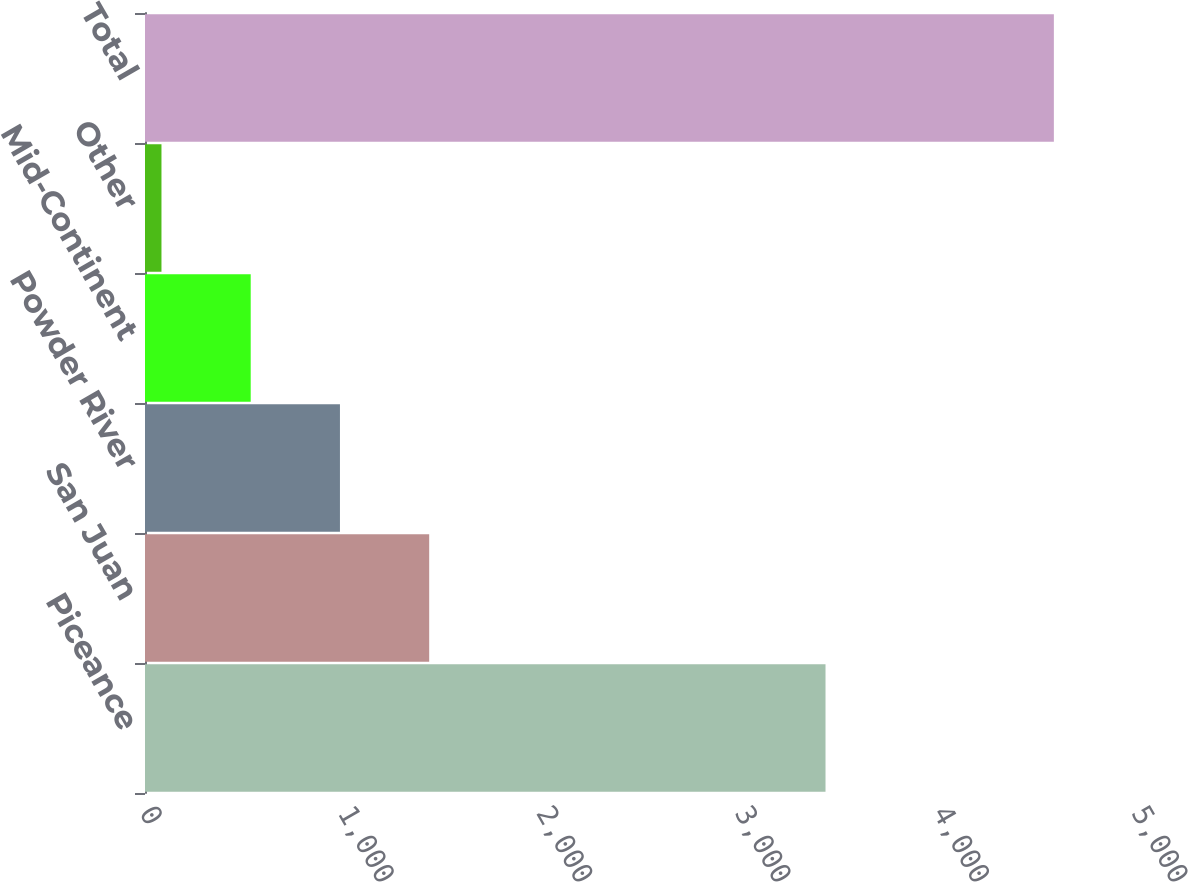Convert chart. <chart><loc_0><loc_0><loc_500><loc_500><bar_chart><fcel>Piceance<fcel>San Juan<fcel>Powder River<fcel>Mid-Continent<fcel>Other<fcel>Total<nl><fcel>3430<fcel>1432.4<fcel>982.6<fcel>532.8<fcel>83<fcel>4581<nl></chart> 